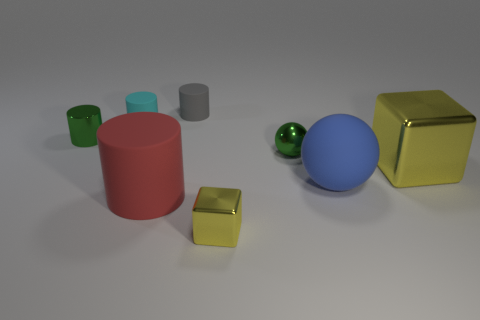What is the color of the small object that is in front of the small green thing right of the small yellow shiny cube?
Make the answer very short. Yellow. How big is the matte cylinder that is in front of the small gray cylinder and behind the shiny ball?
Provide a short and direct response. Small. What number of other objects are the same shape as the small cyan thing?
Your response must be concise. 3. Do the large yellow object and the yellow metal thing that is on the left side of the large blue matte thing have the same shape?
Make the answer very short. Yes. There is a green cylinder; what number of things are behind it?
Your answer should be compact. 2. Are there any other things that are made of the same material as the blue object?
Provide a short and direct response. Yes. Do the yellow thing that is on the left side of the large yellow metallic block and the cyan matte thing have the same shape?
Your answer should be compact. No. There is a small rubber thing that is left of the tiny gray cylinder; what color is it?
Your answer should be compact. Cyan. There is a large thing that is the same material as the large red cylinder; what shape is it?
Make the answer very short. Sphere. Are there any other things that have the same color as the big rubber cylinder?
Provide a succinct answer. No. 